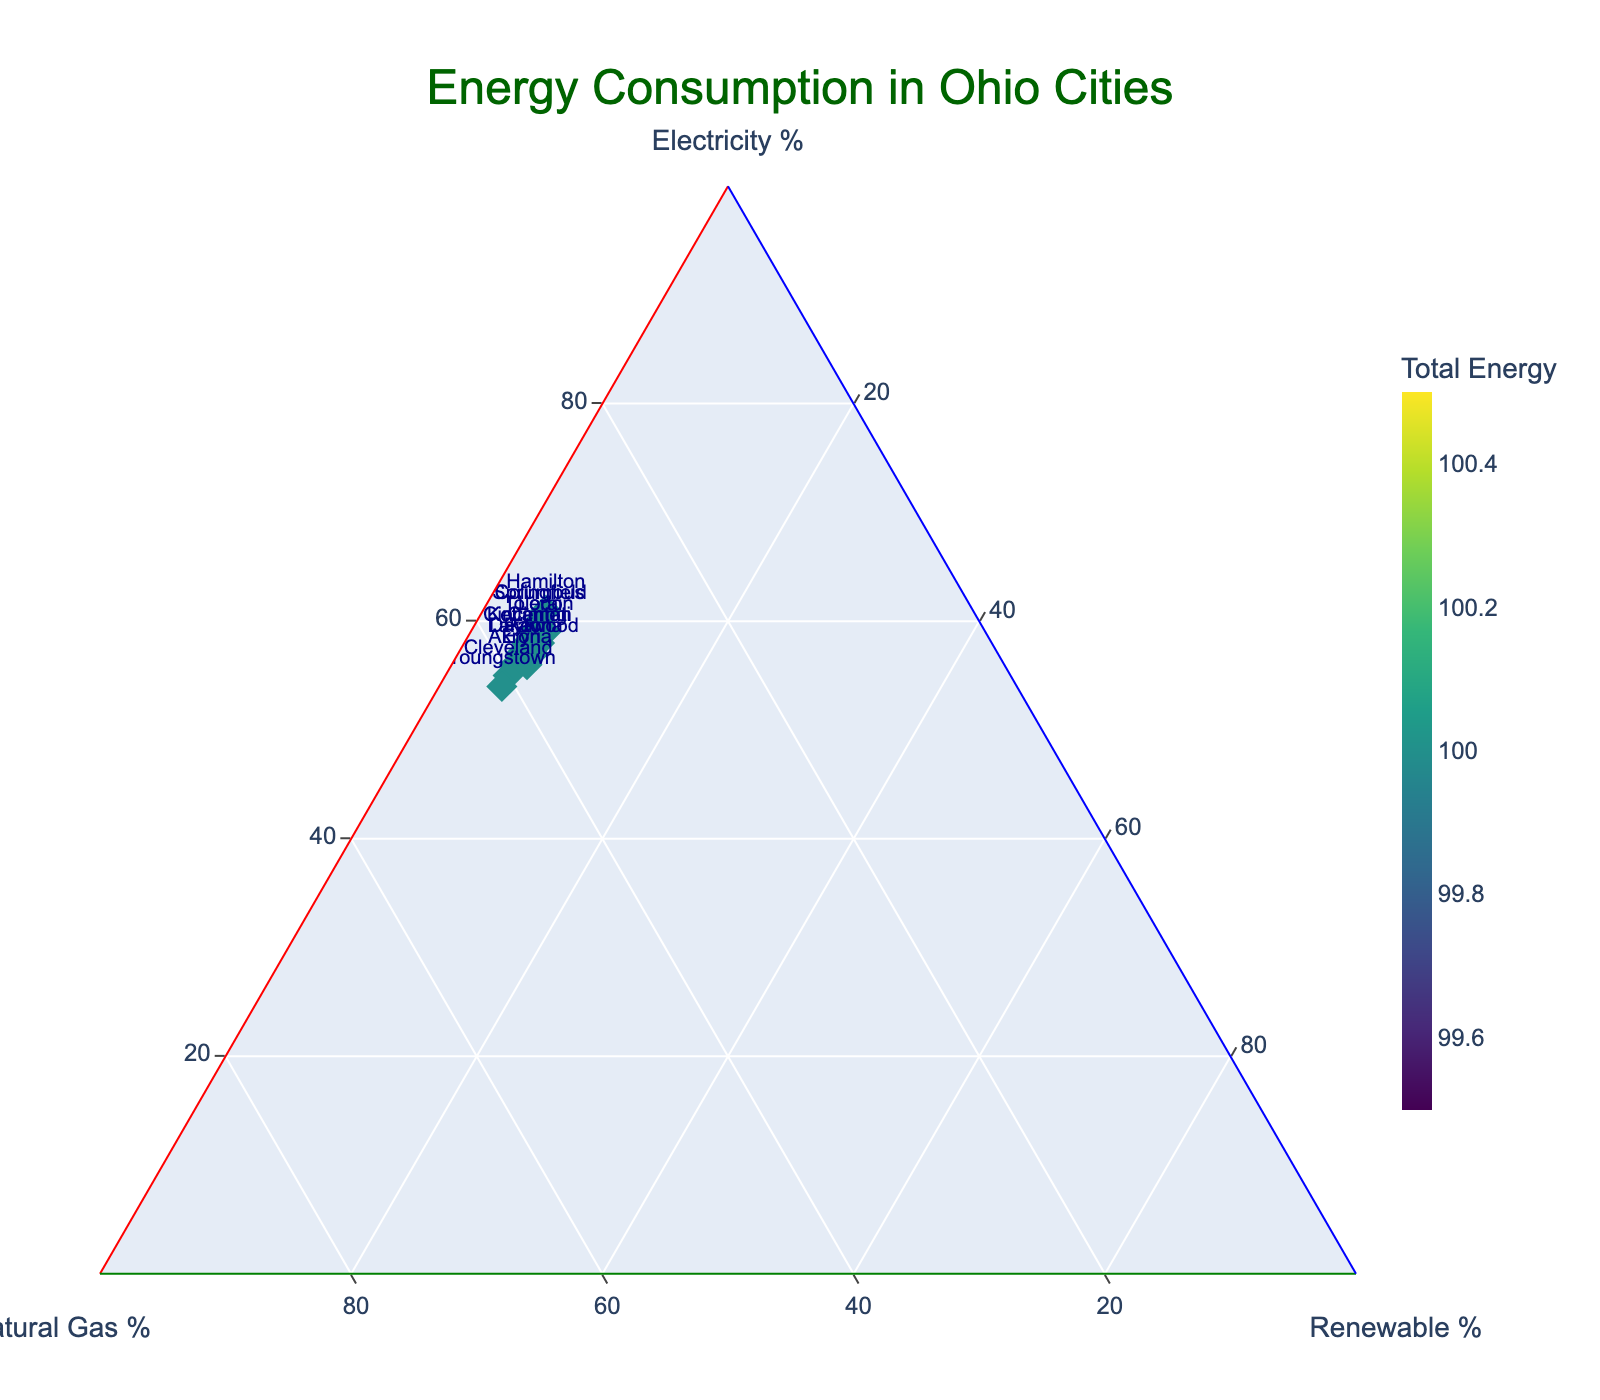What is the title of the figure? The title is usually positioned at the top of the figure and is written in a larger font size than the rest of the text. For this figure, it is "Energy Consumption in Ohio Cities," which describes what the plot represents.
Answer: Energy Consumption in Ohio Cities What are the three energy sources displayed in the figure? The ternary plot divides the data into three axes representing different energy sources. The titles of these axes are "Electricity %," "Natural Gas %," and "Renewable %."
Answer: Electricity, Natural Gas, Renewable Which city has the highest total energy consumption? Total energy consumption can be inferred from the color intensity of the markers. The city with the highest value will have a more intense color. Checking the color bar, the highest is likely colored more towards the end of the spectrum.
Answer: Hamilton What percentage of energy does renewable sources contribute for Canton? For Canton, locate its marker on the ternary plot and find its position relative to the "Renewable %" axis. The vertical distance from the axis determines this value.
Answer: 6% Which cities have exactly 5% of their energy from renewable sources? Find markers positioned within the same vertical line corresponding to 5% of "Renewable %" axis. Cross-referencing with the labels, they are Columbus, Cleveland, Cincinnati, Dayton, Toledo, Akron, Youngstown, Hamilton, Springfield, Kettering.
Answer: Columbus, Cleveland, Cincinnati, Dayton, Toledo, Akron, Youngstown, Hamilton, Springfield, Kettering How do natural gas percentages compare between Cleveland and Columbus? Locate Cleveland and Columbus markers and check their positions in relation to the "Natural Gas %" axis. Cleveland's position is slightly higher than Columbus on this axis.
Answer: Cleveland has a higher percentage Which city has a greater percentage of electricity: Parma or Elyria? Locate Parma and Elyria on the ternary plot and observe their respective positions on the "Electricity %" axis. Parma is positioned slightly higher on this axis.
Answer: Parma What percentage of the total energy does natural gas contribute for Youngstown? Identify Youngstown's marker and follow the corresponding position on the "Natural Gas %" axis, noting the position relative to the scale.
Answer: 41% Are any cities using more than 6% renewable energy? Check each marker against the "Renewable %" axis to determine if any exceed 6%. None of the markers surpass this level.
Answer: No 